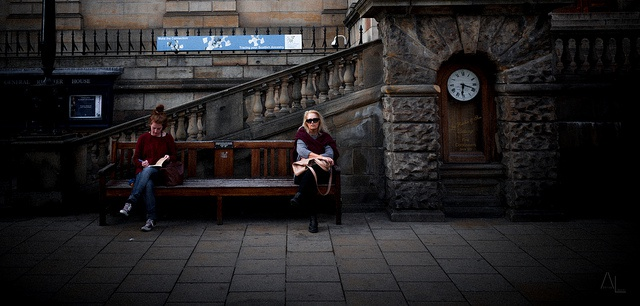Describe the objects in this image and their specific colors. I can see bench in black, gray, and maroon tones, people in black, maroon, navy, and gray tones, people in black, gray, maroon, and lightpink tones, handbag in black, lightgray, maroon, and brown tones, and clock in black and gray tones in this image. 